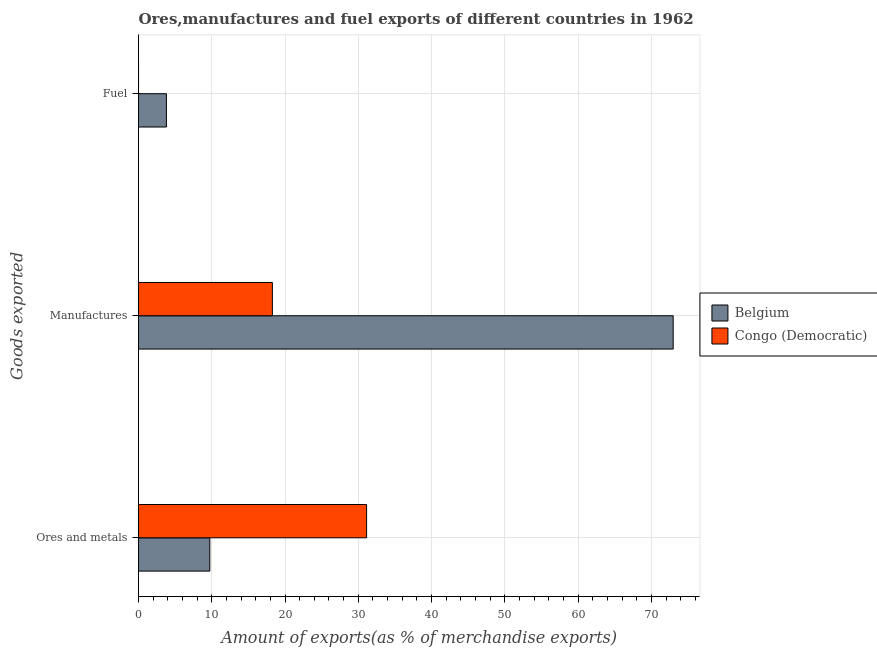How many different coloured bars are there?
Make the answer very short. 2. How many groups of bars are there?
Make the answer very short. 3. Are the number of bars per tick equal to the number of legend labels?
Offer a terse response. Yes. Are the number of bars on each tick of the Y-axis equal?
Offer a terse response. Yes. How many bars are there on the 3rd tick from the bottom?
Make the answer very short. 2. What is the label of the 2nd group of bars from the top?
Your answer should be compact. Manufactures. What is the percentage of fuel exports in Belgium?
Give a very brief answer. 3.81. Across all countries, what is the maximum percentage of manufactures exports?
Your answer should be very brief. 72.98. Across all countries, what is the minimum percentage of fuel exports?
Provide a succinct answer. 0. What is the total percentage of ores and metals exports in the graph?
Keep it short and to the point. 40.87. What is the difference between the percentage of fuel exports in Congo (Democratic) and that in Belgium?
Your answer should be compact. -3.81. What is the difference between the percentage of ores and metals exports in Congo (Democratic) and the percentage of manufactures exports in Belgium?
Keep it short and to the point. -41.85. What is the average percentage of ores and metals exports per country?
Provide a succinct answer. 20.43. What is the difference between the percentage of fuel exports and percentage of manufactures exports in Belgium?
Offer a terse response. -69.17. What is the ratio of the percentage of fuel exports in Congo (Democratic) to that in Belgium?
Ensure brevity in your answer.  0. Is the difference between the percentage of manufactures exports in Congo (Democratic) and Belgium greater than the difference between the percentage of ores and metals exports in Congo (Democratic) and Belgium?
Your response must be concise. No. What is the difference between the highest and the second highest percentage of manufactures exports?
Offer a terse response. 54.71. What is the difference between the highest and the lowest percentage of fuel exports?
Make the answer very short. 3.81. Is the sum of the percentage of fuel exports in Belgium and Congo (Democratic) greater than the maximum percentage of manufactures exports across all countries?
Provide a short and direct response. No. What does the 1st bar from the top in Fuel represents?
Your answer should be compact. Congo (Democratic). Is it the case that in every country, the sum of the percentage of ores and metals exports and percentage of manufactures exports is greater than the percentage of fuel exports?
Provide a succinct answer. Yes. Are all the bars in the graph horizontal?
Ensure brevity in your answer.  Yes. Are the values on the major ticks of X-axis written in scientific E-notation?
Offer a very short reply. No. How many legend labels are there?
Keep it short and to the point. 2. What is the title of the graph?
Your response must be concise. Ores,manufactures and fuel exports of different countries in 1962. What is the label or title of the X-axis?
Keep it short and to the point. Amount of exports(as % of merchandise exports). What is the label or title of the Y-axis?
Make the answer very short. Goods exported. What is the Amount of exports(as % of merchandise exports) in Belgium in Ores and metals?
Provide a short and direct response. 9.73. What is the Amount of exports(as % of merchandise exports) in Congo (Democratic) in Ores and metals?
Provide a succinct answer. 31.13. What is the Amount of exports(as % of merchandise exports) in Belgium in Manufactures?
Provide a short and direct response. 72.98. What is the Amount of exports(as % of merchandise exports) in Congo (Democratic) in Manufactures?
Offer a terse response. 18.27. What is the Amount of exports(as % of merchandise exports) of Belgium in Fuel?
Your answer should be compact. 3.81. What is the Amount of exports(as % of merchandise exports) in Congo (Democratic) in Fuel?
Your answer should be compact. 0. Across all Goods exported, what is the maximum Amount of exports(as % of merchandise exports) of Belgium?
Your answer should be compact. 72.98. Across all Goods exported, what is the maximum Amount of exports(as % of merchandise exports) in Congo (Democratic)?
Your response must be concise. 31.13. Across all Goods exported, what is the minimum Amount of exports(as % of merchandise exports) in Belgium?
Your response must be concise. 3.81. Across all Goods exported, what is the minimum Amount of exports(as % of merchandise exports) in Congo (Democratic)?
Provide a succinct answer. 0. What is the total Amount of exports(as % of merchandise exports) in Belgium in the graph?
Offer a terse response. 86.52. What is the total Amount of exports(as % of merchandise exports) in Congo (Democratic) in the graph?
Make the answer very short. 49.4. What is the difference between the Amount of exports(as % of merchandise exports) in Belgium in Ores and metals and that in Manufactures?
Your answer should be very brief. -63.25. What is the difference between the Amount of exports(as % of merchandise exports) in Congo (Democratic) in Ores and metals and that in Manufactures?
Offer a terse response. 12.86. What is the difference between the Amount of exports(as % of merchandise exports) of Belgium in Ores and metals and that in Fuel?
Give a very brief answer. 5.92. What is the difference between the Amount of exports(as % of merchandise exports) of Congo (Democratic) in Ores and metals and that in Fuel?
Your response must be concise. 31.13. What is the difference between the Amount of exports(as % of merchandise exports) in Belgium in Manufactures and that in Fuel?
Your answer should be very brief. 69.17. What is the difference between the Amount of exports(as % of merchandise exports) of Congo (Democratic) in Manufactures and that in Fuel?
Ensure brevity in your answer.  18.27. What is the difference between the Amount of exports(as % of merchandise exports) in Belgium in Ores and metals and the Amount of exports(as % of merchandise exports) in Congo (Democratic) in Manufactures?
Your response must be concise. -8.54. What is the difference between the Amount of exports(as % of merchandise exports) in Belgium in Ores and metals and the Amount of exports(as % of merchandise exports) in Congo (Democratic) in Fuel?
Your answer should be compact. 9.73. What is the difference between the Amount of exports(as % of merchandise exports) of Belgium in Manufactures and the Amount of exports(as % of merchandise exports) of Congo (Democratic) in Fuel?
Provide a succinct answer. 72.98. What is the average Amount of exports(as % of merchandise exports) in Belgium per Goods exported?
Offer a very short reply. 28.84. What is the average Amount of exports(as % of merchandise exports) in Congo (Democratic) per Goods exported?
Give a very brief answer. 16.47. What is the difference between the Amount of exports(as % of merchandise exports) in Belgium and Amount of exports(as % of merchandise exports) in Congo (Democratic) in Ores and metals?
Your answer should be very brief. -21.4. What is the difference between the Amount of exports(as % of merchandise exports) in Belgium and Amount of exports(as % of merchandise exports) in Congo (Democratic) in Manufactures?
Keep it short and to the point. 54.71. What is the difference between the Amount of exports(as % of merchandise exports) in Belgium and Amount of exports(as % of merchandise exports) in Congo (Democratic) in Fuel?
Ensure brevity in your answer.  3.81. What is the ratio of the Amount of exports(as % of merchandise exports) of Belgium in Ores and metals to that in Manufactures?
Your response must be concise. 0.13. What is the ratio of the Amount of exports(as % of merchandise exports) of Congo (Democratic) in Ores and metals to that in Manufactures?
Your answer should be compact. 1.7. What is the ratio of the Amount of exports(as % of merchandise exports) in Belgium in Ores and metals to that in Fuel?
Provide a short and direct response. 2.55. What is the ratio of the Amount of exports(as % of merchandise exports) in Congo (Democratic) in Ores and metals to that in Fuel?
Give a very brief answer. 5.60e+04. What is the ratio of the Amount of exports(as % of merchandise exports) in Belgium in Manufactures to that in Fuel?
Provide a short and direct response. 19.15. What is the ratio of the Amount of exports(as % of merchandise exports) in Congo (Democratic) in Manufactures to that in Fuel?
Give a very brief answer. 3.28e+04. What is the difference between the highest and the second highest Amount of exports(as % of merchandise exports) in Belgium?
Your response must be concise. 63.25. What is the difference between the highest and the second highest Amount of exports(as % of merchandise exports) of Congo (Democratic)?
Keep it short and to the point. 12.86. What is the difference between the highest and the lowest Amount of exports(as % of merchandise exports) of Belgium?
Offer a terse response. 69.17. What is the difference between the highest and the lowest Amount of exports(as % of merchandise exports) in Congo (Democratic)?
Offer a very short reply. 31.13. 